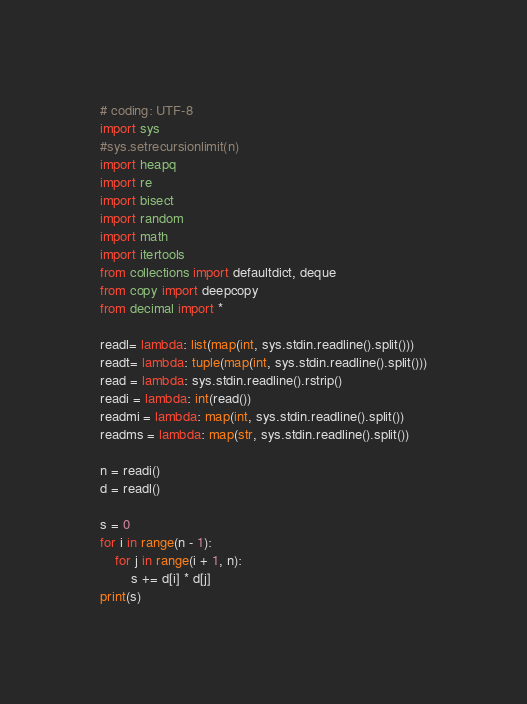Convert code to text. <code><loc_0><loc_0><loc_500><loc_500><_Python_># coding: UTF-8
import sys
#sys.setrecursionlimit(n)
import heapq
import re
import bisect
import random
import math
import itertools
from collections import defaultdict, deque
from copy import deepcopy
from decimal import *

readl= lambda: list(map(int, sys.stdin.readline().split()))
readt= lambda: tuple(map(int, sys.stdin.readline().split()))
read = lambda: sys.stdin.readline().rstrip()
readi = lambda: int(read())
readmi = lambda: map(int, sys.stdin.readline().split())
readms = lambda: map(str, sys.stdin.readline().split())

n = readi()
d = readl()

s = 0
for i in range(n - 1):
    for j in range(i + 1, n):
        s += d[i] * d[j]
print(s)</code> 